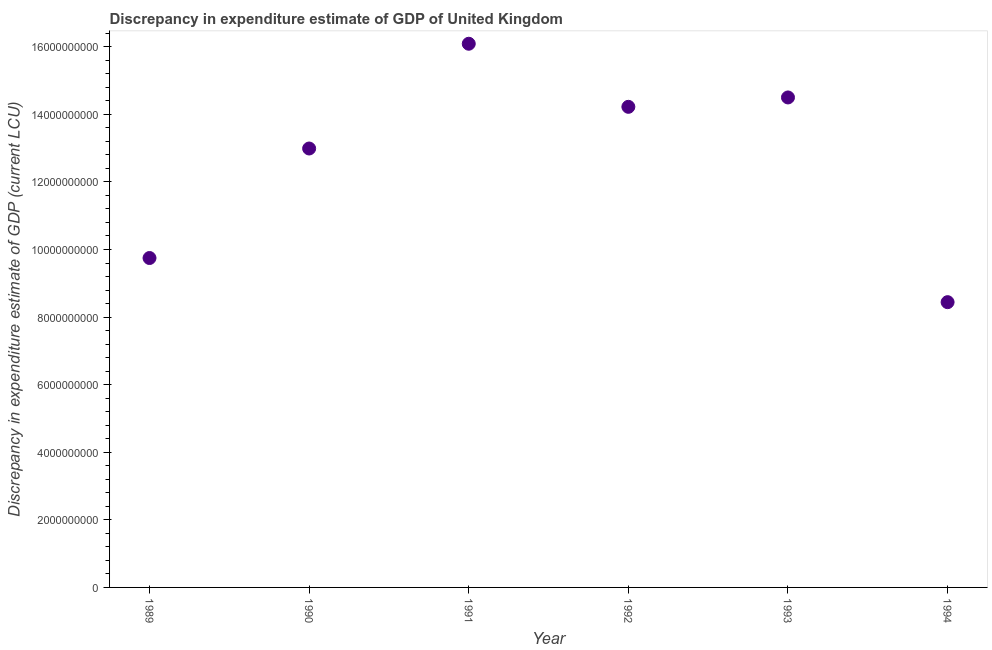What is the discrepancy in expenditure estimate of gdp in 1992?
Make the answer very short. 1.42e+1. Across all years, what is the maximum discrepancy in expenditure estimate of gdp?
Your response must be concise. 1.61e+1. Across all years, what is the minimum discrepancy in expenditure estimate of gdp?
Make the answer very short. 8.44e+09. In which year was the discrepancy in expenditure estimate of gdp maximum?
Your answer should be compact. 1991. In which year was the discrepancy in expenditure estimate of gdp minimum?
Your answer should be compact. 1994. What is the sum of the discrepancy in expenditure estimate of gdp?
Ensure brevity in your answer.  7.60e+1. What is the difference between the discrepancy in expenditure estimate of gdp in 1991 and 1994?
Your response must be concise. 7.65e+09. What is the average discrepancy in expenditure estimate of gdp per year?
Your answer should be compact. 1.27e+1. What is the median discrepancy in expenditure estimate of gdp?
Offer a very short reply. 1.36e+1. What is the ratio of the discrepancy in expenditure estimate of gdp in 1990 to that in 1993?
Give a very brief answer. 0.9. Is the difference between the discrepancy in expenditure estimate of gdp in 1993 and 1994 greater than the difference between any two years?
Offer a very short reply. No. What is the difference between the highest and the second highest discrepancy in expenditure estimate of gdp?
Give a very brief answer. 1.59e+09. What is the difference between the highest and the lowest discrepancy in expenditure estimate of gdp?
Make the answer very short. 7.65e+09. Are the values on the major ticks of Y-axis written in scientific E-notation?
Ensure brevity in your answer.  No. What is the title of the graph?
Offer a terse response. Discrepancy in expenditure estimate of GDP of United Kingdom. What is the label or title of the Y-axis?
Offer a terse response. Discrepancy in expenditure estimate of GDP (current LCU). What is the Discrepancy in expenditure estimate of GDP (current LCU) in 1989?
Make the answer very short. 9.75e+09. What is the Discrepancy in expenditure estimate of GDP (current LCU) in 1990?
Ensure brevity in your answer.  1.30e+1. What is the Discrepancy in expenditure estimate of GDP (current LCU) in 1991?
Your response must be concise. 1.61e+1. What is the Discrepancy in expenditure estimate of GDP (current LCU) in 1992?
Your answer should be very brief. 1.42e+1. What is the Discrepancy in expenditure estimate of GDP (current LCU) in 1993?
Give a very brief answer. 1.45e+1. What is the Discrepancy in expenditure estimate of GDP (current LCU) in 1994?
Keep it short and to the point. 8.44e+09. What is the difference between the Discrepancy in expenditure estimate of GDP (current LCU) in 1989 and 1990?
Ensure brevity in your answer.  -3.24e+09. What is the difference between the Discrepancy in expenditure estimate of GDP (current LCU) in 1989 and 1991?
Give a very brief answer. -6.34e+09. What is the difference between the Discrepancy in expenditure estimate of GDP (current LCU) in 1989 and 1992?
Your answer should be compact. -4.47e+09. What is the difference between the Discrepancy in expenditure estimate of GDP (current LCU) in 1989 and 1993?
Ensure brevity in your answer.  -4.75e+09. What is the difference between the Discrepancy in expenditure estimate of GDP (current LCU) in 1989 and 1994?
Provide a succinct answer. 1.31e+09. What is the difference between the Discrepancy in expenditure estimate of GDP (current LCU) in 1990 and 1991?
Your answer should be compact. -3.10e+09. What is the difference between the Discrepancy in expenditure estimate of GDP (current LCU) in 1990 and 1992?
Your response must be concise. -1.23e+09. What is the difference between the Discrepancy in expenditure estimate of GDP (current LCU) in 1990 and 1993?
Offer a very short reply. -1.51e+09. What is the difference between the Discrepancy in expenditure estimate of GDP (current LCU) in 1990 and 1994?
Offer a terse response. 4.55e+09. What is the difference between the Discrepancy in expenditure estimate of GDP (current LCU) in 1991 and 1992?
Provide a succinct answer. 1.87e+09. What is the difference between the Discrepancy in expenditure estimate of GDP (current LCU) in 1991 and 1993?
Your answer should be compact. 1.59e+09. What is the difference between the Discrepancy in expenditure estimate of GDP (current LCU) in 1991 and 1994?
Give a very brief answer. 7.65e+09. What is the difference between the Discrepancy in expenditure estimate of GDP (current LCU) in 1992 and 1993?
Your answer should be very brief. -2.77e+08. What is the difference between the Discrepancy in expenditure estimate of GDP (current LCU) in 1992 and 1994?
Ensure brevity in your answer.  5.78e+09. What is the difference between the Discrepancy in expenditure estimate of GDP (current LCU) in 1993 and 1994?
Offer a terse response. 6.06e+09. What is the ratio of the Discrepancy in expenditure estimate of GDP (current LCU) in 1989 to that in 1990?
Offer a terse response. 0.75. What is the ratio of the Discrepancy in expenditure estimate of GDP (current LCU) in 1989 to that in 1991?
Give a very brief answer. 0.61. What is the ratio of the Discrepancy in expenditure estimate of GDP (current LCU) in 1989 to that in 1992?
Provide a short and direct response. 0.69. What is the ratio of the Discrepancy in expenditure estimate of GDP (current LCU) in 1989 to that in 1993?
Offer a very short reply. 0.67. What is the ratio of the Discrepancy in expenditure estimate of GDP (current LCU) in 1989 to that in 1994?
Provide a short and direct response. 1.16. What is the ratio of the Discrepancy in expenditure estimate of GDP (current LCU) in 1990 to that in 1991?
Ensure brevity in your answer.  0.81. What is the ratio of the Discrepancy in expenditure estimate of GDP (current LCU) in 1990 to that in 1993?
Keep it short and to the point. 0.9. What is the ratio of the Discrepancy in expenditure estimate of GDP (current LCU) in 1990 to that in 1994?
Keep it short and to the point. 1.54. What is the ratio of the Discrepancy in expenditure estimate of GDP (current LCU) in 1991 to that in 1992?
Your response must be concise. 1.13. What is the ratio of the Discrepancy in expenditure estimate of GDP (current LCU) in 1991 to that in 1993?
Your response must be concise. 1.11. What is the ratio of the Discrepancy in expenditure estimate of GDP (current LCU) in 1991 to that in 1994?
Your answer should be compact. 1.91. What is the ratio of the Discrepancy in expenditure estimate of GDP (current LCU) in 1992 to that in 1994?
Give a very brief answer. 1.69. What is the ratio of the Discrepancy in expenditure estimate of GDP (current LCU) in 1993 to that in 1994?
Offer a very short reply. 1.72. 